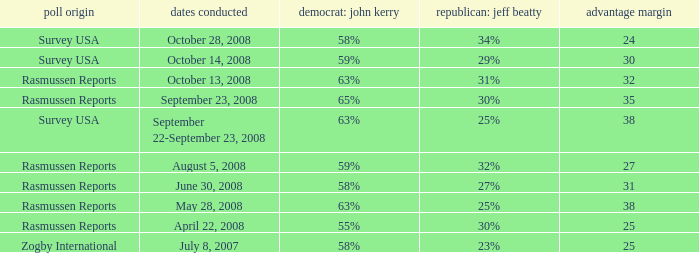Who is the poll source that has Republican: Jeff Beatty behind at 27%? Rasmussen Reports. 